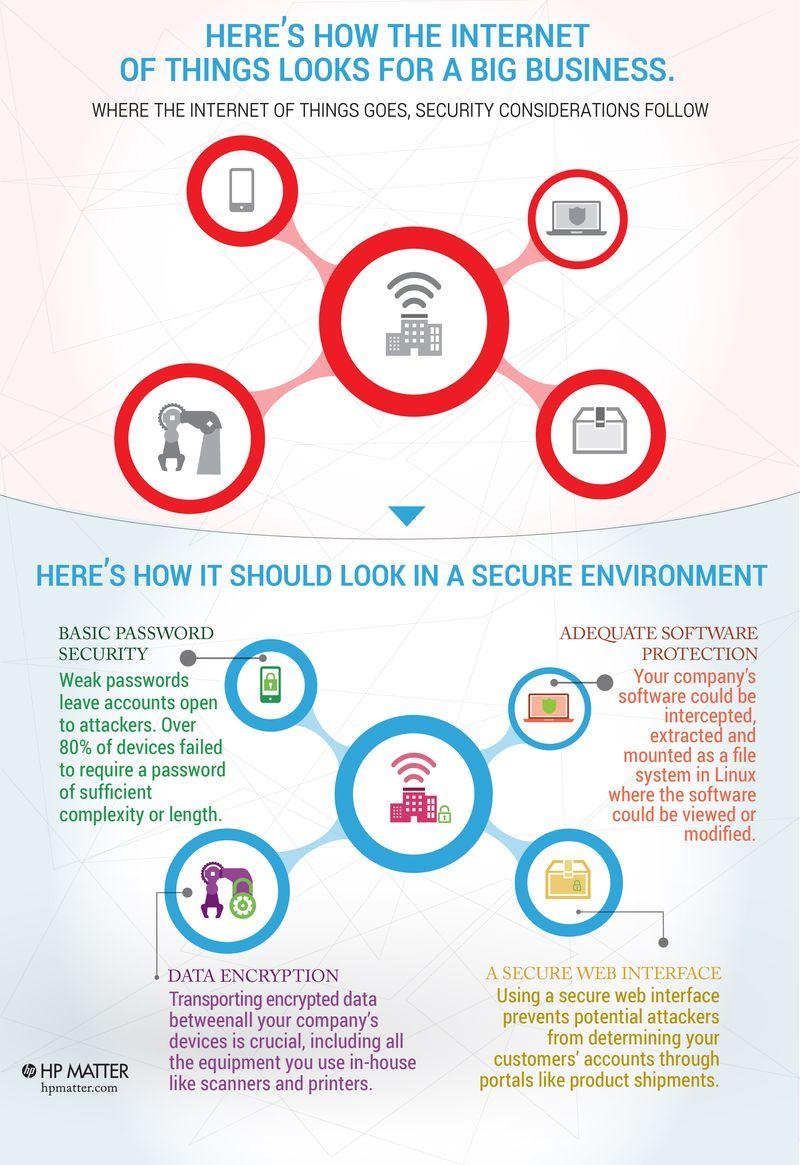Give some essential details in this illustration. Eighty percent of devices lack strong and complex passwords. 